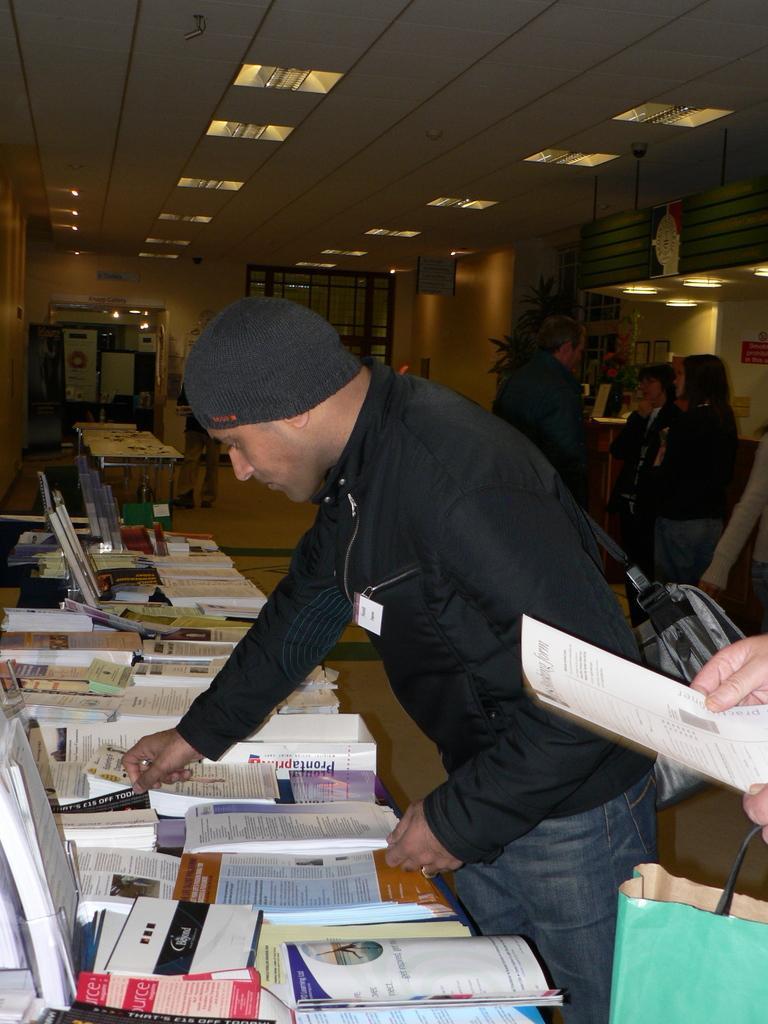Describe this image in one or two sentences. As we can see in the image there are few people here and there, lights and tables. On tables there are laptops, books and papers. 